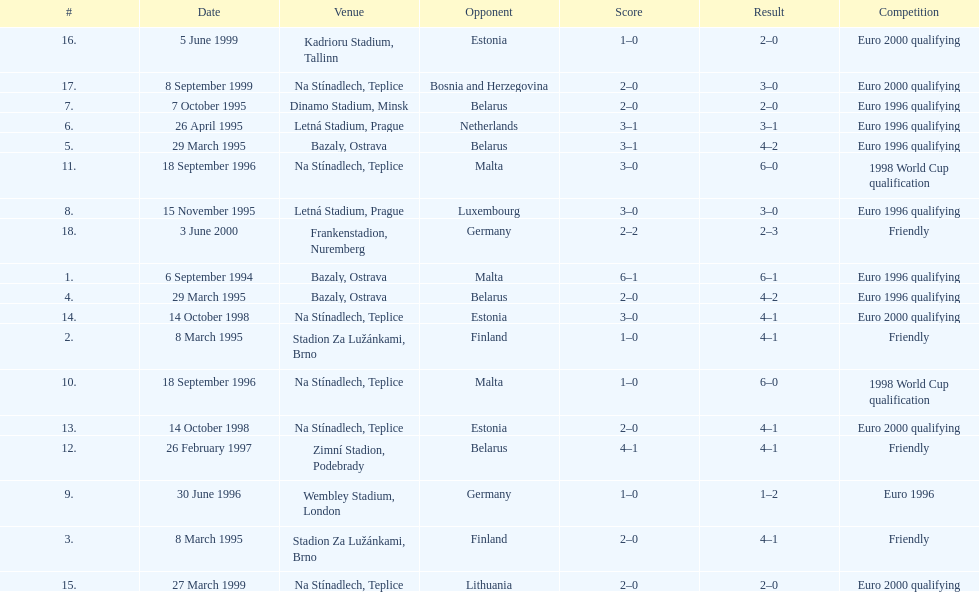What was the number of times czech republic played against germany? 2. 